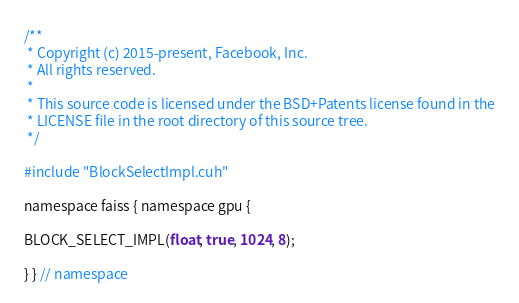Convert code to text. <code><loc_0><loc_0><loc_500><loc_500><_Cuda_>/**
 * Copyright (c) 2015-present, Facebook, Inc.
 * All rights reserved.
 *
 * This source code is licensed under the BSD+Patents license found in the
 * LICENSE file in the root directory of this source tree.
 */

#include "BlockSelectImpl.cuh"

namespace faiss { namespace gpu {

BLOCK_SELECT_IMPL(float, true, 1024, 8);

} } // namespace
</code> 